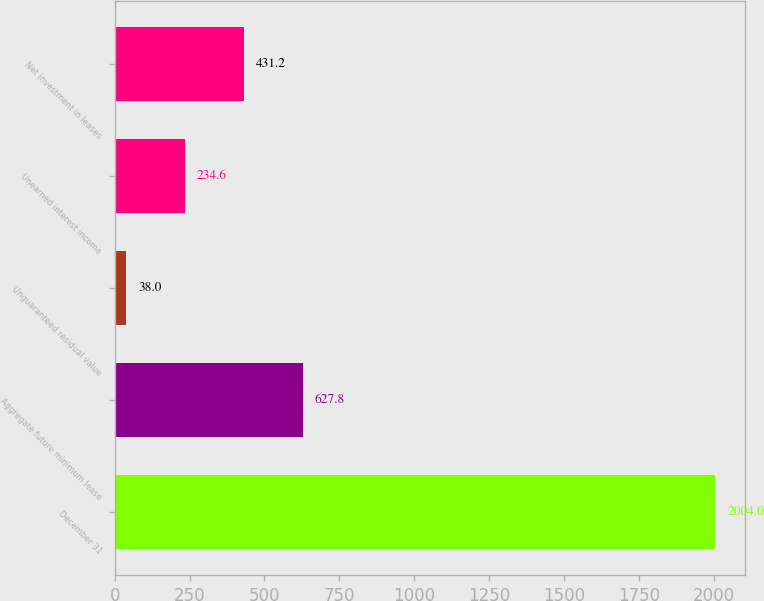Convert chart to OTSL. <chart><loc_0><loc_0><loc_500><loc_500><bar_chart><fcel>December 31<fcel>Aggregate future minimum lease<fcel>Unguaranteed residual value<fcel>Unearned interest income<fcel>Net investment in leases<nl><fcel>2004<fcel>627.8<fcel>38<fcel>234.6<fcel>431.2<nl></chart> 